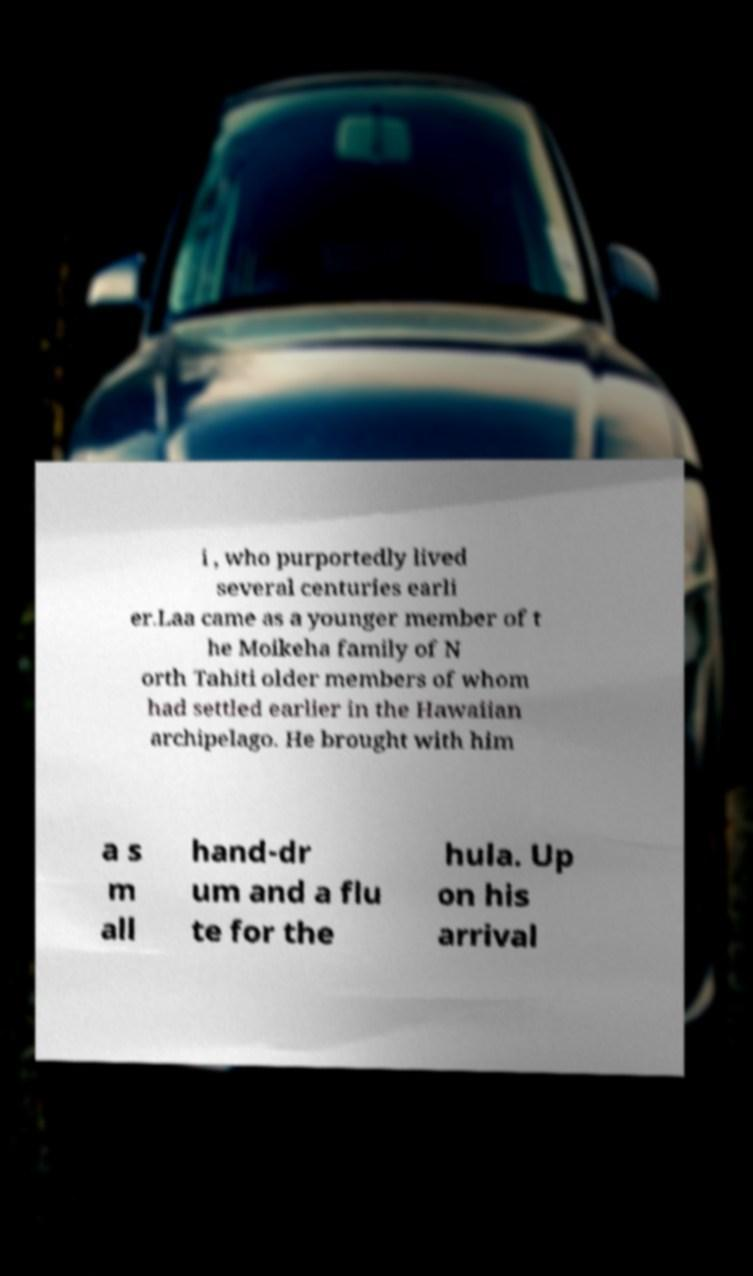What messages or text are displayed in this image? I need them in a readable, typed format. i , who purportedly lived several centuries earli er.Laa came as a younger member of t he Moikeha family of N orth Tahiti older members of whom had settled earlier in the Hawaiian archipelago. He brought with him a s m all hand-dr um and a flu te for the hula. Up on his arrival 